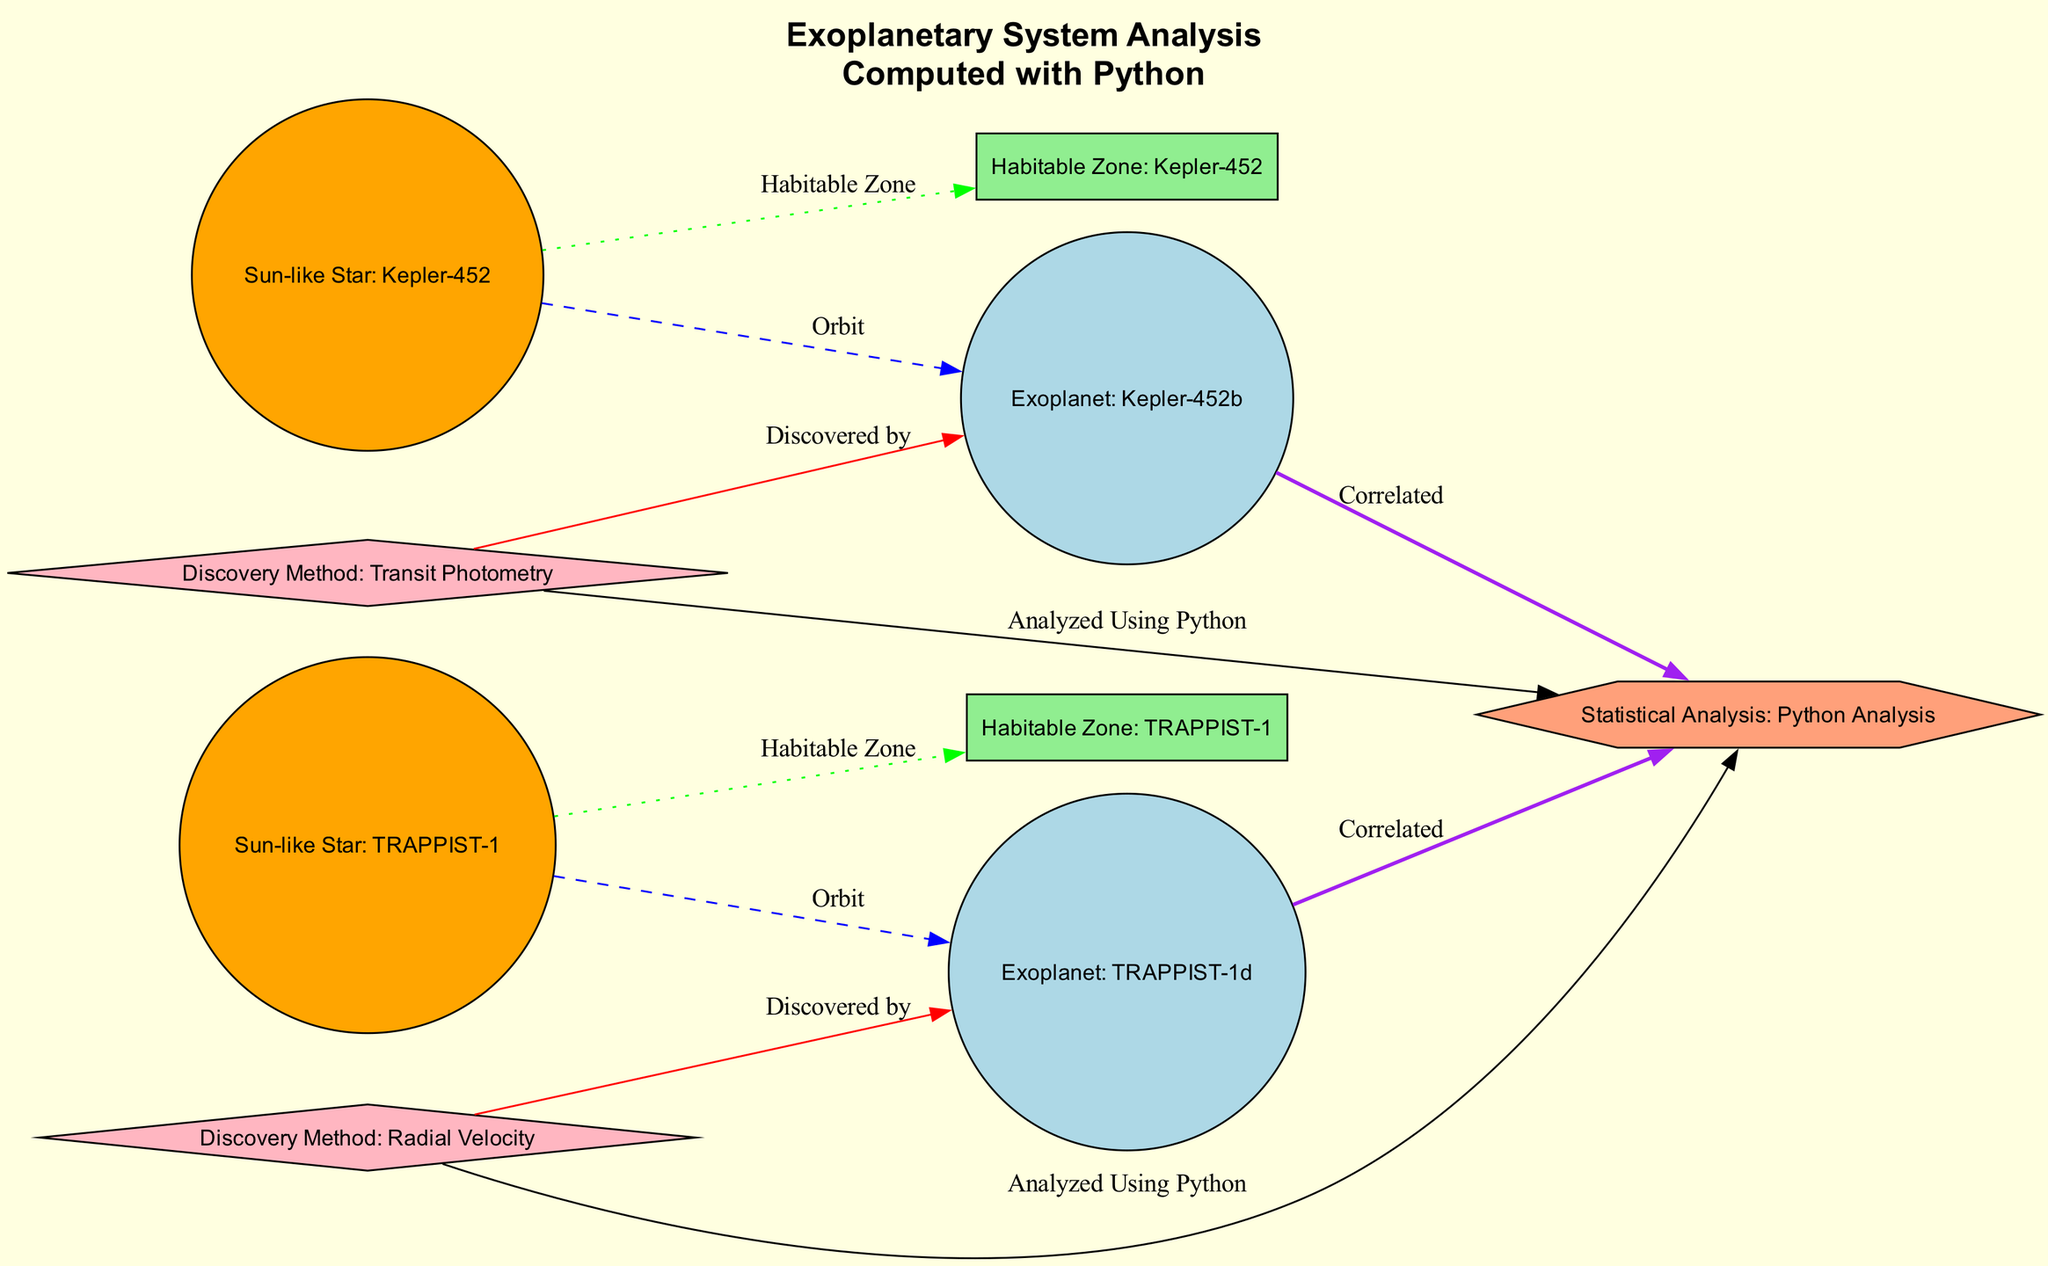What is the label of the first exoplanet shown in the diagram? The diagram lists multiple nodes, including exoplanets. The first exoplanet node in the provided data is labeled as "Exoplanet: Kepler-452b."
Answer: Exoplanet: Kepler-452b How many discovery methods are listed in the diagram? The diagram includes two discovery method nodes, namely "Discovery Method: Transit Photometry" and "Discovery Method: Radial Velocity." Counting these nodes gives a total of two discovery methods.
Answer: 2 What color is used for the habitability zone nodes? According to the data defining the styles of nodes, habitability zones are represented in the color "lightgreen." The nodes specifically labeled with "Habitable Zone" follow this color format.
Answer: lightgreen Which exoplanet is discovered using transit photometry? The relationship illustrated in the diagram indicates that "Exoplanet: Kepler-452b" is connected via the edge labeled "Discovered by" to the node "Discovery Method: Transit Photometry," confirming that it was discovered through this method.
Answer: Exoplanet: Kepler-452b Which sun-like star is associated with the habitability zone labeled for TRAPPIST-1? From the diagram, "Habitability Zone: TRAPPIST-1" connects to "Sun-like Star: TRAPPIST-1," making it clear that the habitability zone is associated with the TRAPPIST-1 star.
Answer: Sun-like Star: TRAPPIST-1 How many orbits are illustrated in the diagram? The diagram showcases two edges labeled as "Orbit," connecting the sun-like stars to their respective exoplanets. Therefore, there are two orbit connections represented.
Answer: 2 Which exoplanet is correlated with statistical analysis through Python? Both "Exoplanet: Kepler-452b" and "Exoplanet: TRAPPIST-1d" are linked by the edge labeled "Correlated" to the "Statistical Analysis: Python Analysis" node, indicating that they both participate in the correlated analysis.
Answer: Exoplanet: Kepler-452b and Exoplanet: TRAPPIST-1d What discovery method is connected to Exoplanet: TRAPPIST-1d? The edge connecting the "Discovery Method: Radial Velocity" node to "Exoplanet: TRAPPIST-1d" indicates that this exoplanet was discovered by this specific method.
Answer: Discovery Method: Radial Velocity How many exoplanets are included in the diagram? The diagram contains two nodes categorized as exoplanets: "Exoplanet: Kepler-452b" and "Exoplanet: TRAPPIST-1d." Counting these gives a total of two exoplanet nodes.
Answer: 2 What is emphasized in the title of the diagram? The title of the diagram specifically mentions "Computed with Python," highlighting the statistical analysis aspect that is integral to the diagram's purpose and analysis approach.
Answer: Computed with Python 